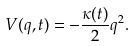<formula> <loc_0><loc_0><loc_500><loc_500>V ( q , t ) = - \frac { \kappa ( t ) } { 2 } q ^ { 2 } .</formula> 